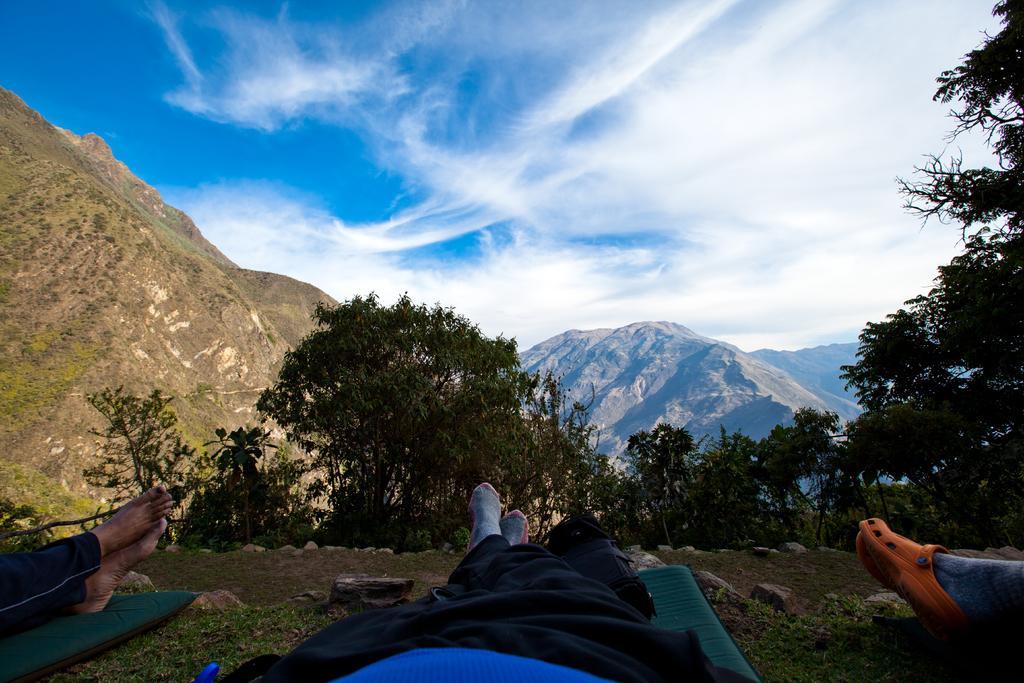Can you describe this image briefly? In this image we can see trees, there are three persons legs on the ground, in front there are mountains, the sky is cloudy. 